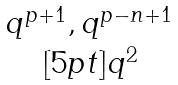Convert formula to latex. <formula><loc_0><loc_0><loc_500><loc_500>\begin{matrix} q ^ { p + 1 } , q ^ { p - n + 1 } \\ [ 5 p t ] q ^ { 2 } \end{matrix}</formula> 